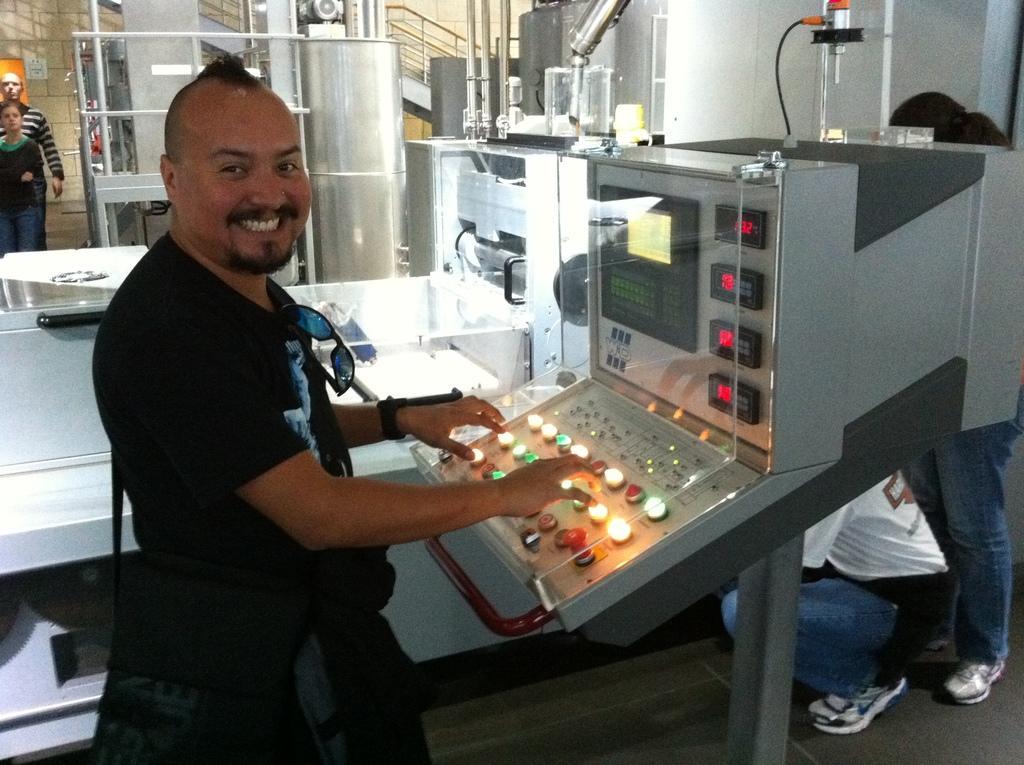Can you describe this image briefly? In this image I see a man over here who is smiling and I see a machine over here on which there are buttons and I see the lights. In the background I see few equipment and I see 4 persons and I see the path. 